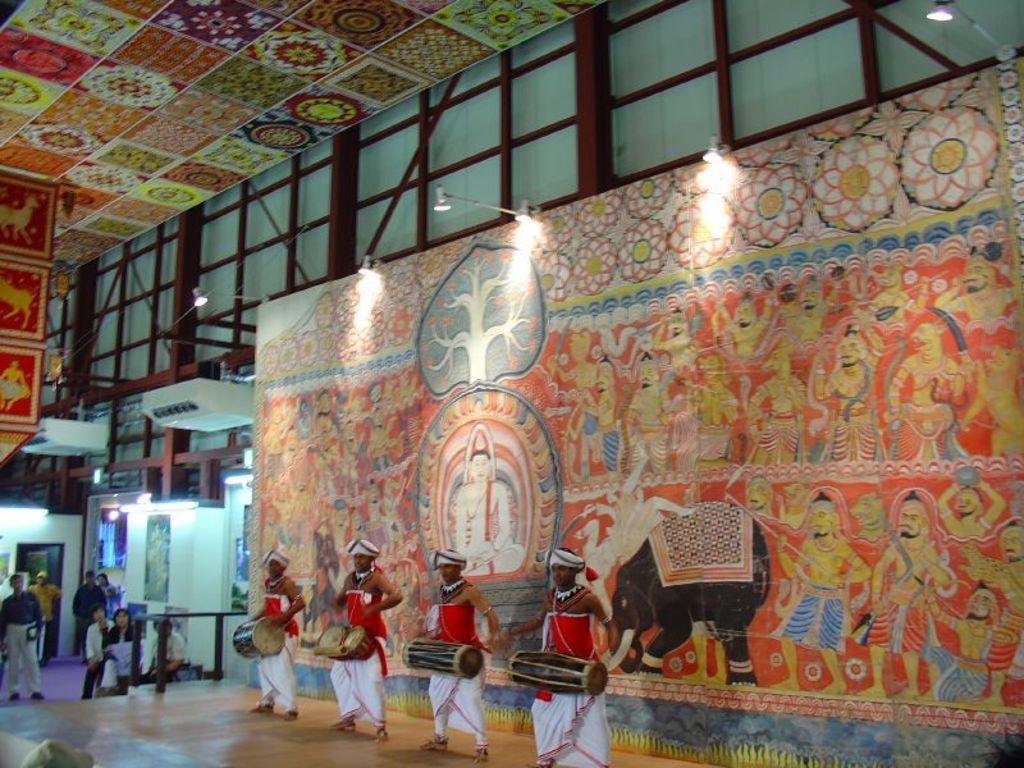Describe this image in one or two sentences. In this image we can see a group of people. Here four persons are holding musical instruments. In the background of the image there is a painted wall. At the top of the image there are lights, iron rods, glasses and ceiling. 